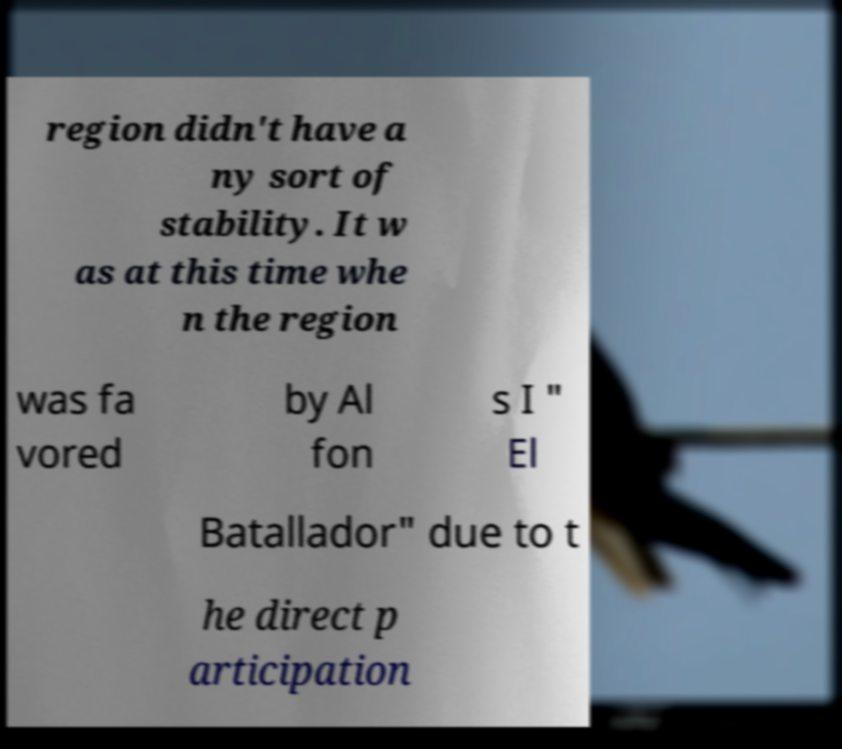Can you read and provide the text displayed in the image?This photo seems to have some interesting text. Can you extract and type it out for me? region didn't have a ny sort of stability. It w as at this time whe n the region was fa vored by Al fon s I " El Batallador" due to t he direct p articipation 